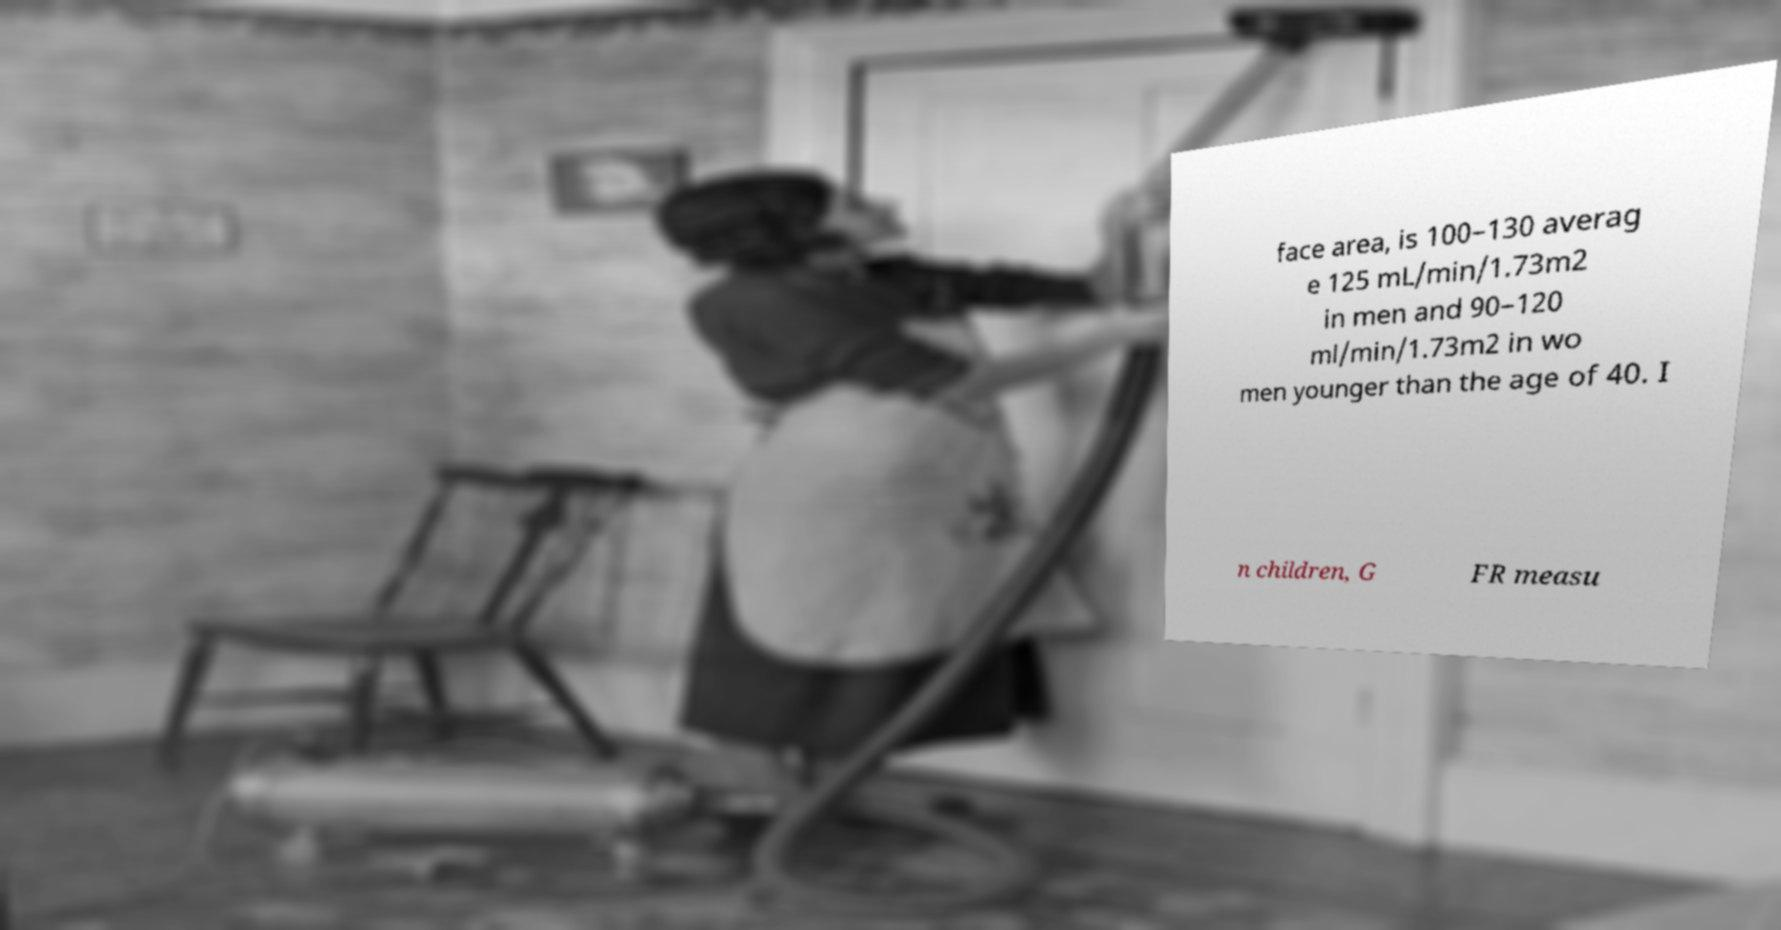Can you read and provide the text displayed in the image?This photo seems to have some interesting text. Can you extract and type it out for me? face area, is 100–130 averag e 125 mL/min/1.73m2 in men and 90–120 ml/min/1.73m2 in wo men younger than the age of 40. I n children, G FR measu 